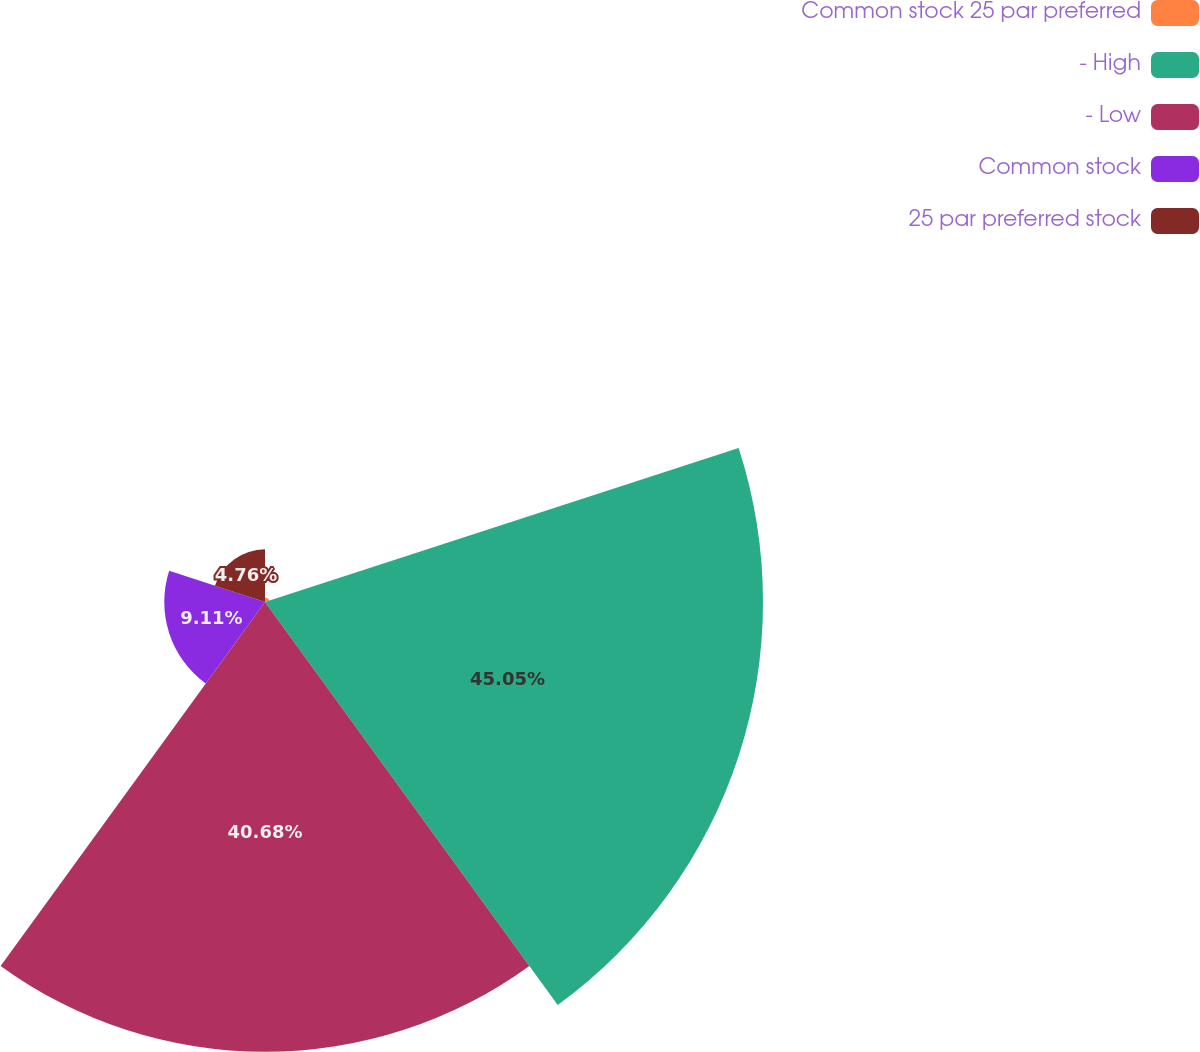Convert chart. <chart><loc_0><loc_0><loc_500><loc_500><pie_chart><fcel>Common stock 25 par preferred<fcel>- High<fcel>- Low<fcel>Common stock<fcel>25 par preferred stock<nl><fcel>0.4%<fcel>45.04%<fcel>40.68%<fcel>9.11%<fcel>4.76%<nl></chart> 